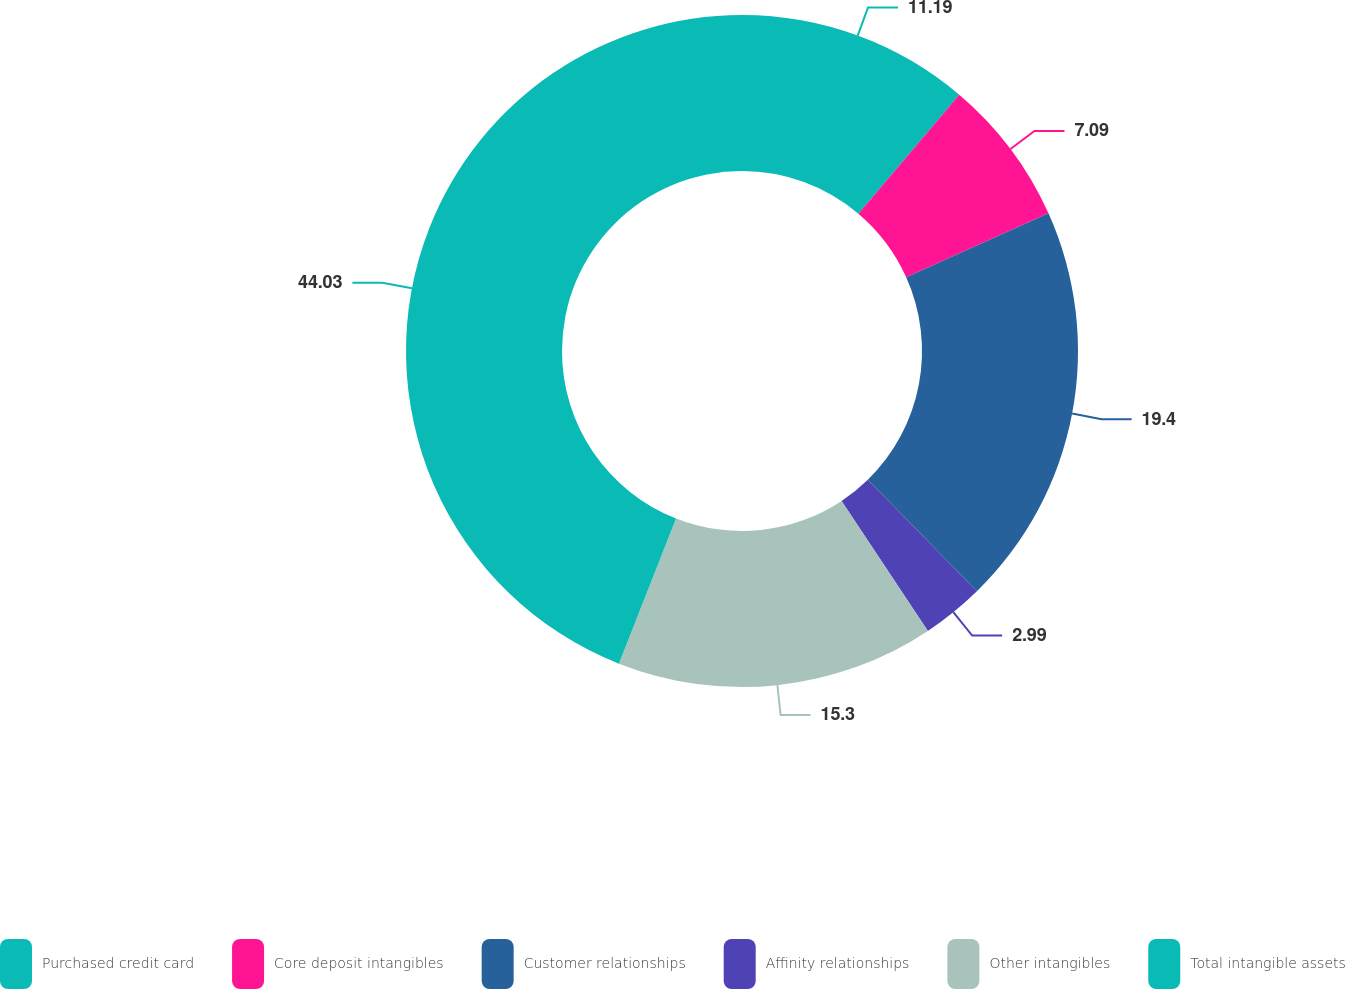Convert chart to OTSL. <chart><loc_0><loc_0><loc_500><loc_500><pie_chart><fcel>Purchased credit card<fcel>Core deposit intangibles<fcel>Customer relationships<fcel>Affinity relationships<fcel>Other intangibles<fcel>Total intangible assets<nl><fcel>11.19%<fcel>7.09%<fcel>19.4%<fcel>2.99%<fcel>15.3%<fcel>44.03%<nl></chart> 